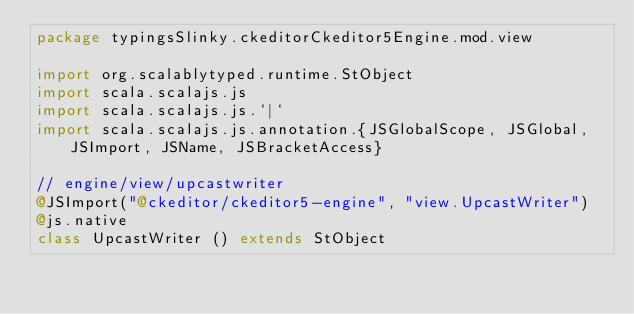<code> <loc_0><loc_0><loc_500><loc_500><_Scala_>package typingsSlinky.ckeditorCkeditor5Engine.mod.view

import org.scalablytyped.runtime.StObject
import scala.scalajs.js
import scala.scalajs.js.`|`
import scala.scalajs.js.annotation.{JSGlobalScope, JSGlobal, JSImport, JSName, JSBracketAccess}

// engine/view/upcastwriter
@JSImport("@ckeditor/ckeditor5-engine", "view.UpcastWriter")
@js.native
class UpcastWriter () extends StObject
</code> 